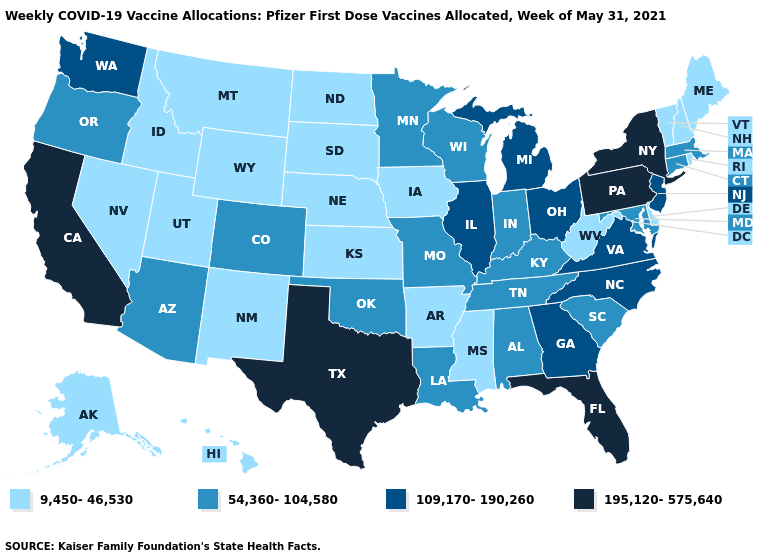Among the states that border North Dakota , which have the lowest value?
Keep it brief. Montana, South Dakota. What is the value of Louisiana?
Keep it brief. 54,360-104,580. Does Texas have a lower value than North Dakota?
Be succinct. No. What is the value of Montana?
Quick response, please. 9,450-46,530. What is the value of North Dakota?
Keep it brief. 9,450-46,530. How many symbols are there in the legend?
Concise answer only. 4. How many symbols are there in the legend?
Answer briefly. 4. Does Colorado have the highest value in the USA?
Give a very brief answer. No. Is the legend a continuous bar?
Give a very brief answer. No. Does Michigan have a lower value than Vermont?
Short answer required. No. What is the highest value in the USA?
Concise answer only. 195,120-575,640. Among the states that border Kansas , which have the lowest value?
Quick response, please. Nebraska. What is the value of Florida?
Short answer required. 195,120-575,640. What is the highest value in states that border West Virginia?
Answer briefly. 195,120-575,640. What is the value of Michigan?
Write a very short answer. 109,170-190,260. 